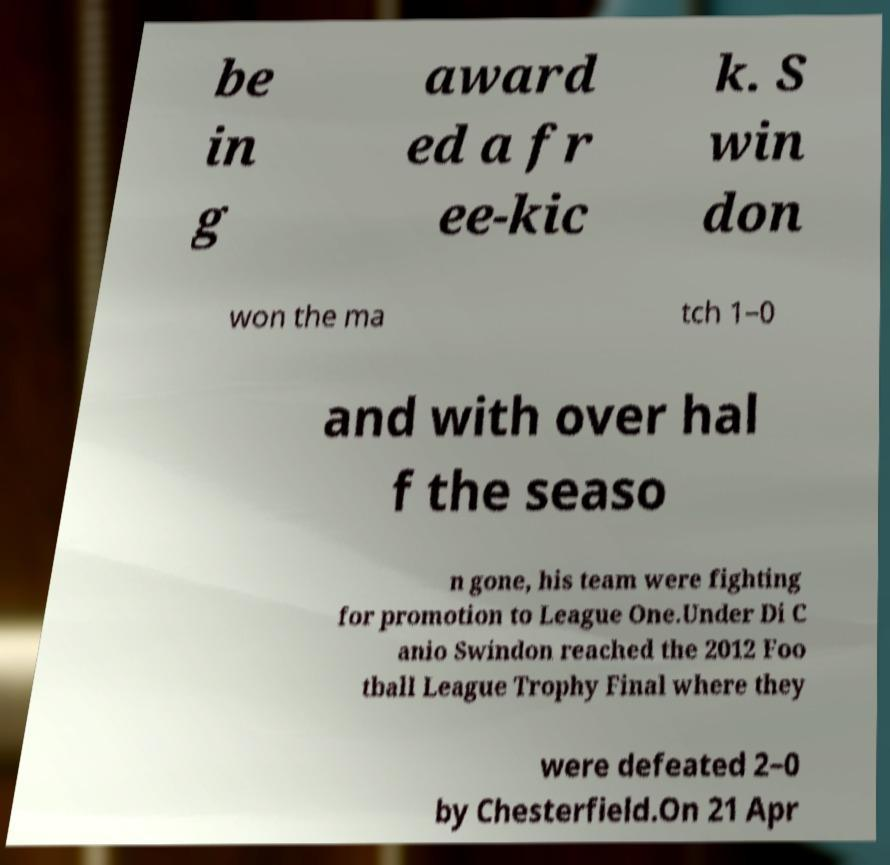Please identify and transcribe the text found in this image. be in g award ed a fr ee-kic k. S win don won the ma tch 1–0 and with over hal f the seaso n gone, his team were fighting for promotion to League One.Under Di C anio Swindon reached the 2012 Foo tball League Trophy Final where they were defeated 2–0 by Chesterfield.On 21 Apr 